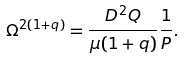Convert formula to latex. <formula><loc_0><loc_0><loc_500><loc_500>\Omega ^ { 2 ( 1 + q ) } = \frac { D ^ { 2 } Q } { \mu ( 1 + q ) } \frac { 1 } { P } .</formula> 